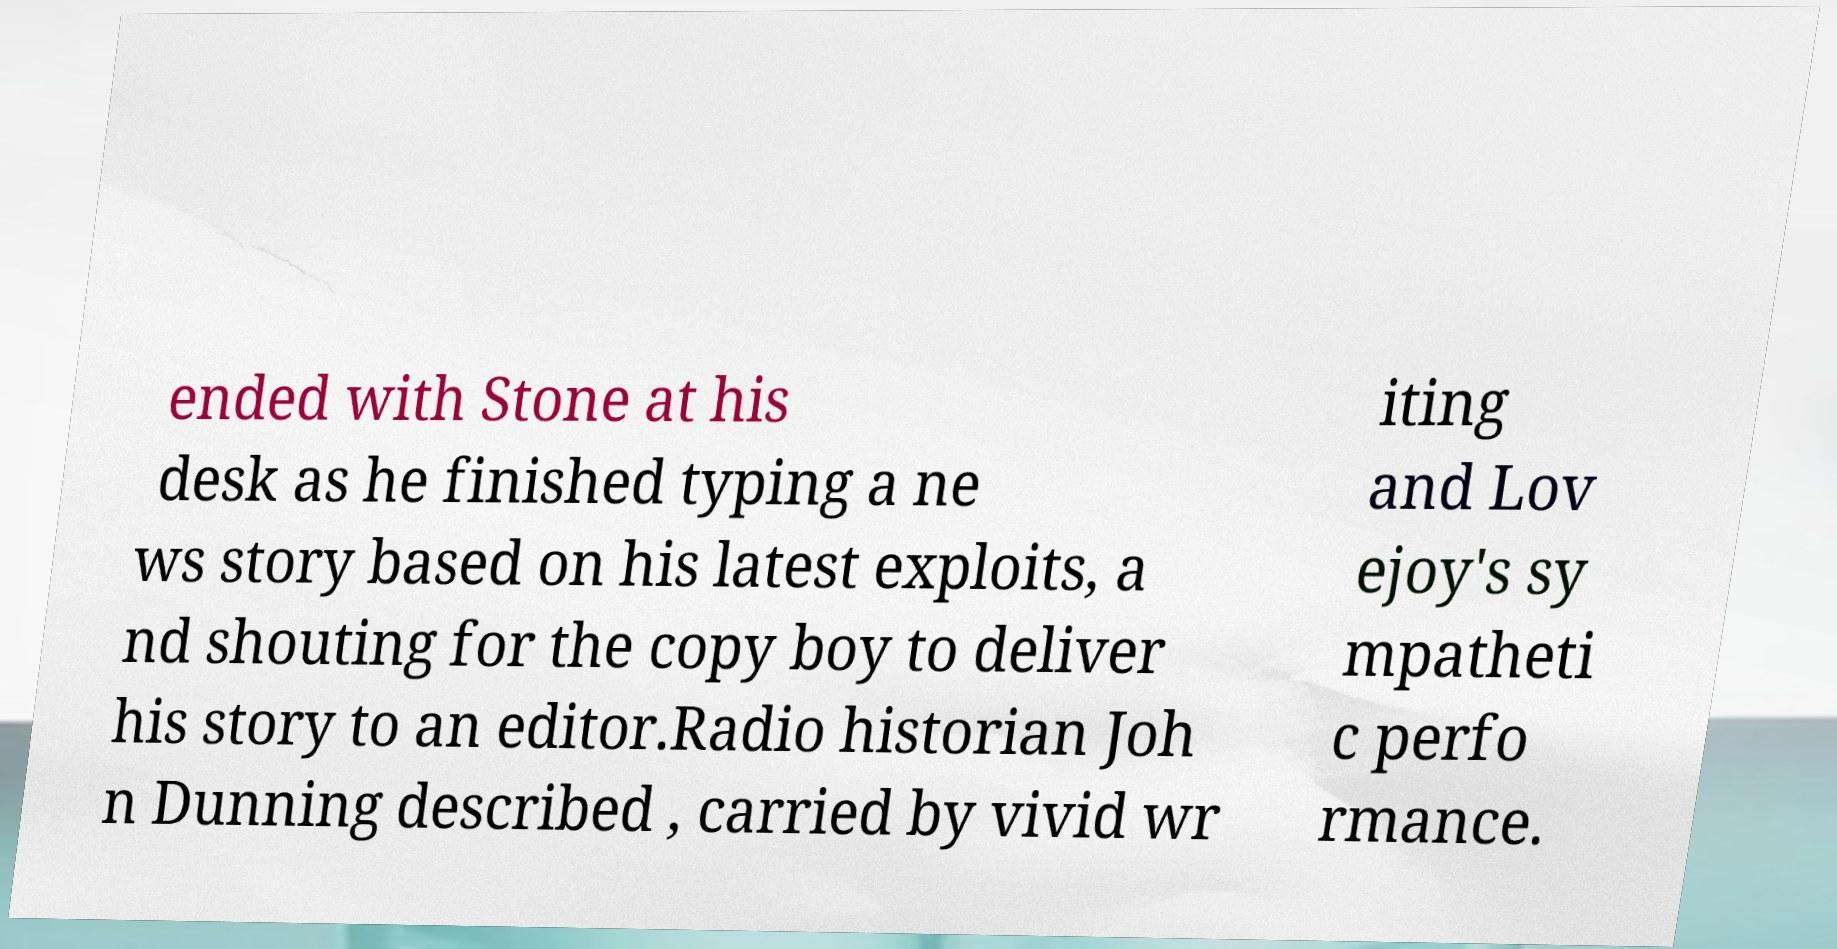What messages or text are displayed in this image? I need them in a readable, typed format. ended with Stone at his desk as he finished typing a ne ws story based on his latest exploits, a nd shouting for the copy boy to deliver his story to an editor.Radio historian Joh n Dunning described , carried by vivid wr iting and Lov ejoy's sy mpatheti c perfo rmance. 